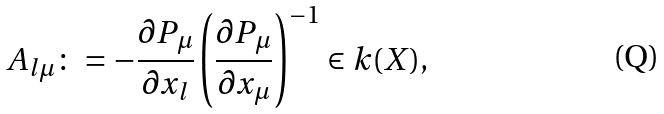<formula> <loc_0><loc_0><loc_500><loc_500>A _ { l \mu } \colon = - \frac { \partial P _ { \mu } } { \partial x _ { l } } \left ( \frac { \partial P _ { \mu } } { \partial x _ { \mu } } \right ) ^ { - 1 } \in k ( X ) ,</formula> 